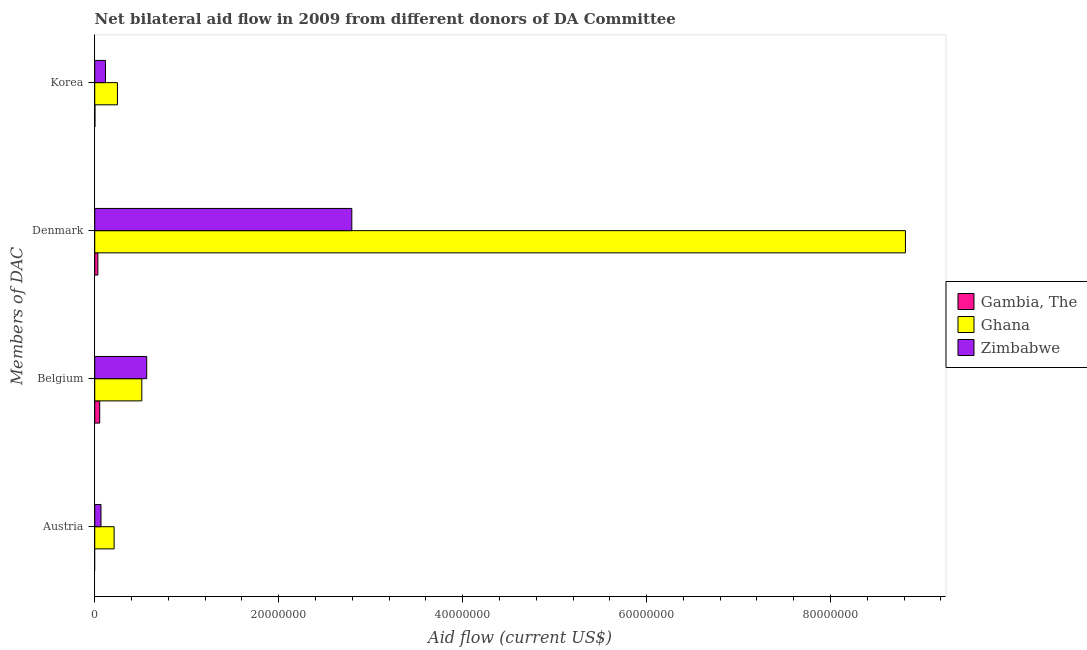How many different coloured bars are there?
Your response must be concise. 3. Are the number of bars per tick equal to the number of legend labels?
Provide a succinct answer. No. Are the number of bars on each tick of the Y-axis equal?
Your answer should be very brief. No. How many bars are there on the 3rd tick from the bottom?
Keep it short and to the point. 3. What is the label of the 1st group of bars from the top?
Provide a succinct answer. Korea. What is the amount of aid given by denmark in Ghana?
Your answer should be compact. 8.81e+07. Across all countries, what is the maximum amount of aid given by belgium?
Your answer should be compact. 5.65e+06. Across all countries, what is the minimum amount of aid given by korea?
Your answer should be compact. 2.00e+04. In which country was the amount of aid given by belgium maximum?
Offer a very short reply. Zimbabwe. What is the total amount of aid given by denmark in the graph?
Give a very brief answer. 1.16e+08. What is the difference between the amount of aid given by denmark in Ghana and that in Zimbabwe?
Offer a very short reply. 6.02e+07. What is the difference between the amount of aid given by korea in Gambia, The and the amount of aid given by belgium in Zimbabwe?
Your answer should be compact. -5.63e+06. What is the average amount of aid given by austria per country?
Give a very brief answer. 9.30e+05. What is the difference between the amount of aid given by denmark and amount of aid given by korea in Zimbabwe?
Offer a terse response. 2.68e+07. In how many countries, is the amount of aid given by korea greater than 4000000 US$?
Your response must be concise. 0. What is the ratio of the amount of aid given by belgium in Ghana to that in Zimbabwe?
Give a very brief answer. 0.91. Is the difference between the amount of aid given by denmark in Zimbabwe and Gambia, The greater than the difference between the amount of aid given by korea in Zimbabwe and Gambia, The?
Your answer should be compact. Yes. What is the difference between the highest and the second highest amount of aid given by denmark?
Keep it short and to the point. 6.02e+07. What is the difference between the highest and the lowest amount of aid given by austria?
Keep it short and to the point. 2.11e+06. In how many countries, is the amount of aid given by belgium greater than the average amount of aid given by belgium taken over all countries?
Offer a very short reply. 2. Is the sum of the amount of aid given by belgium in Zimbabwe and Ghana greater than the maximum amount of aid given by korea across all countries?
Your answer should be very brief. Yes. Is it the case that in every country, the sum of the amount of aid given by austria and amount of aid given by denmark is greater than the sum of amount of aid given by belgium and amount of aid given by korea?
Offer a terse response. No. Is it the case that in every country, the sum of the amount of aid given by austria and amount of aid given by belgium is greater than the amount of aid given by denmark?
Offer a very short reply. No. How many bars are there?
Give a very brief answer. 11. What is the difference between two consecutive major ticks on the X-axis?
Your answer should be compact. 2.00e+07. What is the title of the graph?
Make the answer very short. Net bilateral aid flow in 2009 from different donors of DA Committee. Does "Dominican Republic" appear as one of the legend labels in the graph?
Provide a succinct answer. No. What is the label or title of the X-axis?
Offer a terse response. Aid flow (current US$). What is the label or title of the Y-axis?
Provide a succinct answer. Members of DAC. What is the Aid flow (current US$) of Gambia, The in Austria?
Your response must be concise. 0. What is the Aid flow (current US$) in Ghana in Austria?
Offer a very short reply. 2.11e+06. What is the Aid flow (current US$) in Zimbabwe in Austria?
Your answer should be compact. 6.80e+05. What is the Aid flow (current US$) in Gambia, The in Belgium?
Offer a terse response. 5.40e+05. What is the Aid flow (current US$) in Ghana in Belgium?
Your response must be concise. 5.12e+06. What is the Aid flow (current US$) of Zimbabwe in Belgium?
Offer a very short reply. 5.65e+06. What is the Aid flow (current US$) of Ghana in Denmark?
Provide a short and direct response. 8.81e+07. What is the Aid flow (current US$) in Zimbabwe in Denmark?
Your response must be concise. 2.80e+07. What is the Aid flow (current US$) of Ghana in Korea?
Your response must be concise. 2.47e+06. What is the Aid flow (current US$) in Zimbabwe in Korea?
Make the answer very short. 1.17e+06. Across all Members of DAC, what is the maximum Aid flow (current US$) of Gambia, The?
Give a very brief answer. 5.40e+05. Across all Members of DAC, what is the maximum Aid flow (current US$) of Ghana?
Your response must be concise. 8.81e+07. Across all Members of DAC, what is the maximum Aid flow (current US$) in Zimbabwe?
Your answer should be compact. 2.80e+07. Across all Members of DAC, what is the minimum Aid flow (current US$) of Ghana?
Give a very brief answer. 2.11e+06. Across all Members of DAC, what is the minimum Aid flow (current US$) of Zimbabwe?
Keep it short and to the point. 6.80e+05. What is the total Aid flow (current US$) of Ghana in the graph?
Give a very brief answer. 9.78e+07. What is the total Aid flow (current US$) in Zimbabwe in the graph?
Your answer should be very brief. 3.54e+07. What is the difference between the Aid flow (current US$) in Ghana in Austria and that in Belgium?
Make the answer very short. -3.01e+06. What is the difference between the Aid flow (current US$) in Zimbabwe in Austria and that in Belgium?
Your answer should be compact. -4.97e+06. What is the difference between the Aid flow (current US$) of Ghana in Austria and that in Denmark?
Your response must be concise. -8.60e+07. What is the difference between the Aid flow (current US$) in Zimbabwe in Austria and that in Denmark?
Your answer should be compact. -2.73e+07. What is the difference between the Aid flow (current US$) in Ghana in Austria and that in Korea?
Provide a succinct answer. -3.60e+05. What is the difference between the Aid flow (current US$) in Zimbabwe in Austria and that in Korea?
Your response must be concise. -4.90e+05. What is the difference between the Aid flow (current US$) of Ghana in Belgium and that in Denmark?
Keep it short and to the point. -8.30e+07. What is the difference between the Aid flow (current US$) in Zimbabwe in Belgium and that in Denmark?
Provide a short and direct response. -2.23e+07. What is the difference between the Aid flow (current US$) in Gambia, The in Belgium and that in Korea?
Make the answer very short. 5.20e+05. What is the difference between the Aid flow (current US$) in Ghana in Belgium and that in Korea?
Make the answer very short. 2.65e+06. What is the difference between the Aid flow (current US$) in Zimbabwe in Belgium and that in Korea?
Your answer should be compact. 4.48e+06. What is the difference between the Aid flow (current US$) in Gambia, The in Denmark and that in Korea?
Make the answer very short. 3.20e+05. What is the difference between the Aid flow (current US$) of Ghana in Denmark and that in Korea?
Your answer should be very brief. 8.57e+07. What is the difference between the Aid flow (current US$) in Zimbabwe in Denmark and that in Korea?
Your response must be concise. 2.68e+07. What is the difference between the Aid flow (current US$) of Ghana in Austria and the Aid flow (current US$) of Zimbabwe in Belgium?
Provide a succinct answer. -3.54e+06. What is the difference between the Aid flow (current US$) of Ghana in Austria and the Aid flow (current US$) of Zimbabwe in Denmark?
Ensure brevity in your answer.  -2.58e+07. What is the difference between the Aid flow (current US$) of Ghana in Austria and the Aid flow (current US$) of Zimbabwe in Korea?
Ensure brevity in your answer.  9.40e+05. What is the difference between the Aid flow (current US$) of Gambia, The in Belgium and the Aid flow (current US$) of Ghana in Denmark?
Your answer should be very brief. -8.76e+07. What is the difference between the Aid flow (current US$) of Gambia, The in Belgium and the Aid flow (current US$) of Zimbabwe in Denmark?
Provide a succinct answer. -2.74e+07. What is the difference between the Aid flow (current US$) in Ghana in Belgium and the Aid flow (current US$) in Zimbabwe in Denmark?
Provide a succinct answer. -2.28e+07. What is the difference between the Aid flow (current US$) in Gambia, The in Belgium and the Aid flow (current US$) in Ghana in Korea?
Keep it short and to the point. -1.93e+06. What is the difference between the Aid flow (current US$) of Gambia, The in Belgium and the Aid flow (current US$) of Zimbabwe in Korea?
Keep it short and to the point. -6.30e+05. What is the difference between the Aid flow (current US$) of Ghana in Belgium and the Aid flow (current US$) of Zimbabwe in Korea?
Provide a succinct answer. 3.95e+06. What is the difference between the Aid flow (current US$) of Gambia, The in Denmark and the Aid flow (current US$) of Ghana in Korea?
Make the answer very short. -2.13e+06. What is the difference between the Aid flow (current US$) of Gambia, The in Denmark and the Aid flow (current US$) of Zimbabwe in Korea?
Your answer should be compact. -8.30e+05. What is the difference between the Aid flow (current US$) of Ghana in Denmark and the Aid flow (current US$) of Zimbabwe in Korea?
Make the answer very short. 8.70e+07. What is the average Aid flow (current US$) in Gambia, The per Members of DAC?
Your response must be concise. 2.25e+05. What is the average Aid flow (current US$) of Ghana per Members of DAC?
Provide a succinct answer. 2.45e+07. What is the average Aid flow (current US$) of Zimbabwe per Members of DAC?
Offer a terse response. 8.86e+06. What is the difference between the Aid flow (current US$) of Ghana and Aid flow (current US$) of Zimbabwe in Austria?
Offer a very short reply. 1.43e+06. What is the difference between the Aid flow (current US$) in Gambia, The and Aid flow (current US$) in Ghana in Belgium?
Your answer should be very brief. -4.58e+06. What is the difference between the Aid flow (current US$) of Gambia, The and Aid flow (current US$) of Zimbabwe in Belgium?
Give a very brief answer. -5.11e+06. What is the difference between the Aid flow (current US$) of Ghana and Aid flow (current US$) of Zimbabwe in Belgium?
Your answer should be very brief. -5.30e+05. What is the difference between the Aid flow (current US$) in Gambia, The and Aid flow (current US$) in Ghana in Denmark?
Give a very brief answer. -8.78e+07. What is the difference between the Aid flow (current US$) in Gambia, The and Aid flow (current US$) in Zimbabwe in Denmark?
Provide a short and direct response. -2.76e+07. What is the difference between the Aid flow (current US$) in Ghana and Aid flow (current US$) in Zimbabwe in Denmark?
Your answer should be very brief. 6.02e+07. What is the difference between the Aid flow (current US$) in Gambia, The and Aid flow (current US$) in Ghana in Korea?
Your answer should be very brief. -2.45e+06. What is the difference between the Aid flow (current US$) in Gambia, The and Aid flow (current US$) in Zimbabwe in Korea?
Your response must be concise. -1.15e+06. What is the difference between the Aid flow (current US$) in Ghana and Aid flow (current US$) in Zimbabwe in Korea?
Give a very brief answer. 1.30e+06. What is the ratio of the Aid flow (current US$) in Ghana in Austria to that in Belgium?
Your answer should be very brief. 0.41. What is the ratio of the Aid flow (current US$) of Zimbabwe in Austria to that in Belgium?
Provide a short and direct response. 0.12. What is the ratio of the Aid flow (current US$) of Ghana in Austria to that in Denmark?
Provide a succinct answer. 0.02. What is the ratio of the Aid flow (current US$) of Zimbabwe in Austria to that in Denmark?
Ensure brevity in your answer.  0.02. What is the ratio of the Aid flow (current US$) in Ghana in Austria to that in Korea?
Keep it short and to the point. 0.85. What is the ratio of the Aid flow (current US$) of Zimbabwe in Austria to that in Korea?
Your response must be concise. 0.58. What is the ratio of the Aid flow (current US$) of Gambia, The in Belgium to that in Denmark?
Keep it short and to the point. 1.59. What is the ratio of the Aid flow (current US$) in Ghana in Belgium to that in Denmark?
Make the answer very short. 0.06. What is the ratio of the Aid flow (current US$) in Zimbabwe in Belgium to that in Denmark?
Keep it short and to the point. 0.2. What is the ratio of the Aid flow (current US$) of Ghana in Belgium to that in Korea?
Offer a very short reply. 2.07. What is the ratio of the Aid flow (current US$) of Zimbabwe in Belgium to that in Korea?
Your answer should be very brief. 4.83. What is the ratio of the Aid flow (current US$) of Gambia, The in Denmark to that in Korea?
Your answer should be compact. 17. What is the ratio of the Aid flow (current US$) of Ghana in Denmark to that in Korea?
Give a very brief answer. 35.68. What is the ratio of the Aid flow (current US$) in Zimbabwe in Denmark to that in Korea?
Keep it short and to the point. 23.89. What is the difference between the highest and the second highest Aid flow (current US$) in Gambia, The?
Keep it short and to the point. 2.00e+05. What is the difference between the highest and the second highest Aid flow (current US$) in Ghana?
Ensure brevity in your answer.  8.30e+07. What is the difference between the highest and the second highest Aid flow (current US$) in Zimbabwe?
Provide a succinct answer. 2.23e+07. What is the difference between the highest and the lowest Aid flow (current US$) of Gambia, The?
Ensure brevity in your answer.  5.40e+05. What is the difference between the highest and the lowest Aid flow (current US$) in Ghana?
Offer a very short reply. 8.60e+07. What is the difference between the highest and the lowest Aid flow (current US$) of Zimbabwe?
Make the answer very short. 2.73e+07. 